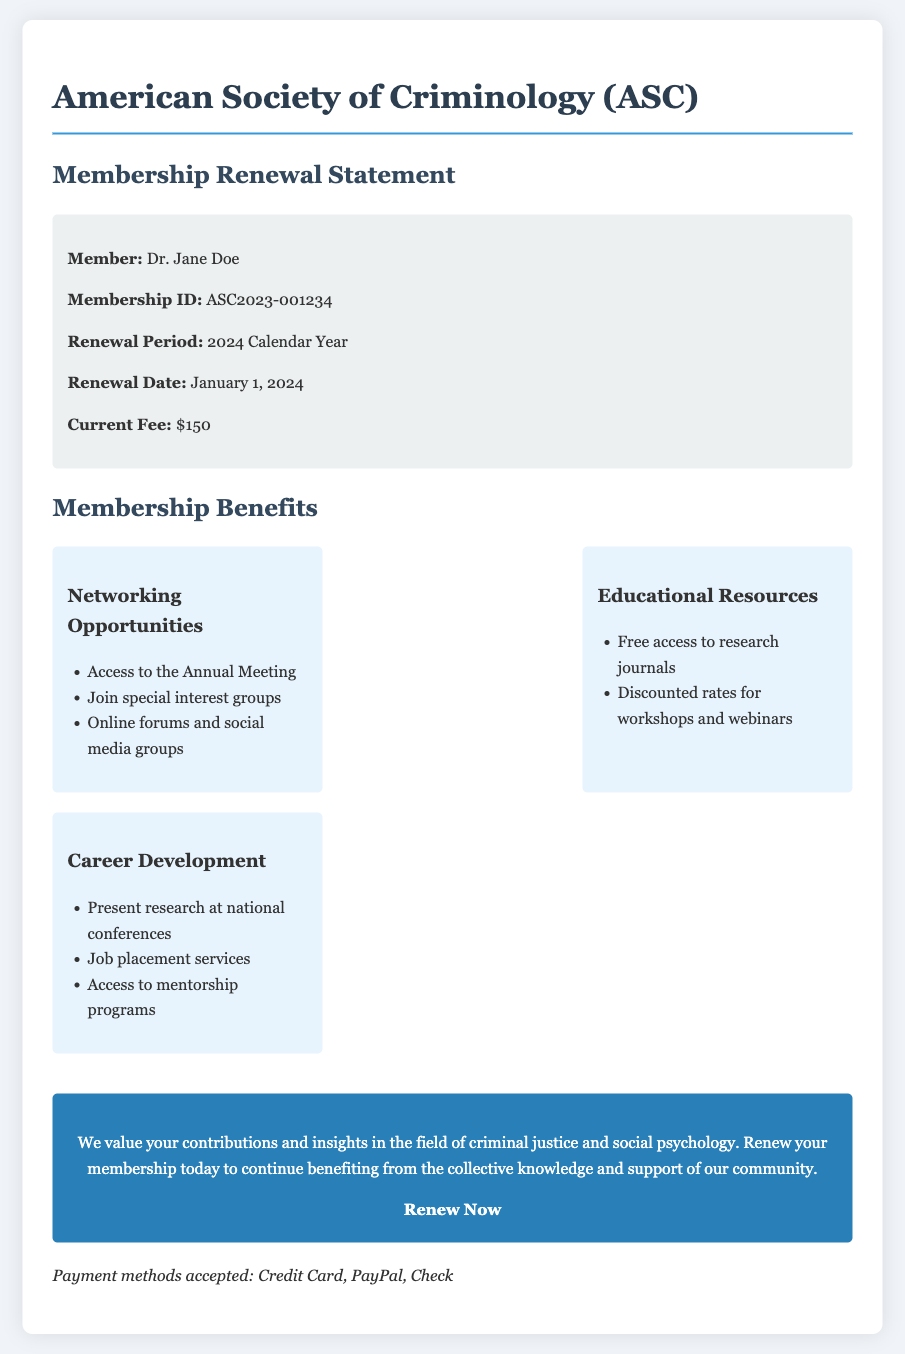What is the name of the organization? The organization name is provided in the document header.
Answer: American Society of Criminology (ASC) Who is the member? The member's name is stated in the membership info section of the document.
Answer: Dr. Jane Doe What is the membership fee? The current fee is mentioned in the member info section of the document.
Answer: $150 What is the renewal period? The renewal period is specified in the member info section.
Answer: 2024 Calendar Year What networking opportunity is mentioned? The document lists specific networking opportunities under membership benefits.
Answer: Access to the Annual Meeting How many benefit categories are there? The benefits section features three distinct categories.
Answer: Three What kind of payment methods are accepted? The acceptable payment methods are listed at the bottom of the document.
Answer: Credit Card, PayPal, Check What is the renewal date? The renewal date is clearly mentioned in the membership info section.
Answer: January 1, 2024 What is one educational resource provided? The document specifies one type of educational resource in the membership benefits.
Answer: Free access to research journals 